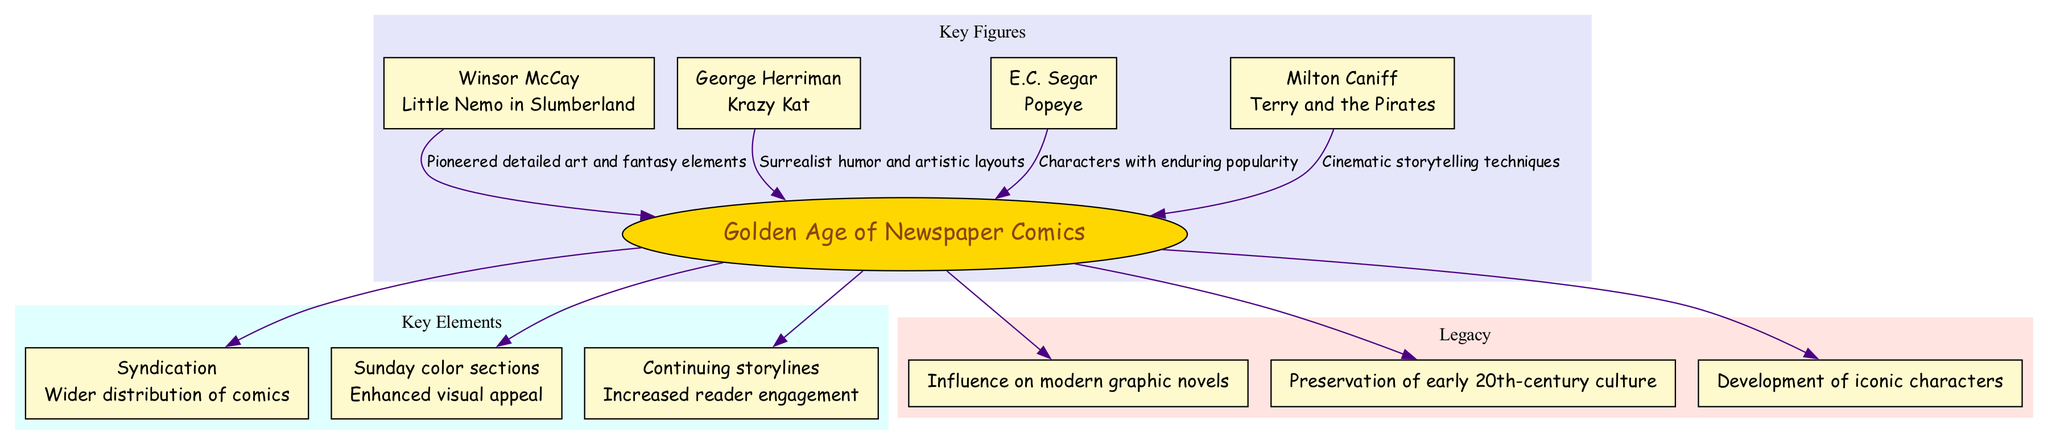What is the central concept of the diagram? The central concept is explicitly labeled in the diagram as the main focus, which is "Golden Age of Newspaper Comics".
Answer: Golden Age of Newspaper Comics How many key figures are included in the diagram? Count the number of nodes listed under the "Key Figures" section in the diagram; there are four distinct figures represented.
Answer: 4 What is the contribution of George Herriman? The diagram shows that George Herriman's contribution is "Krazy Kat," which is clearly stated under his name in the "Key Figures" section.
Answer: Krazy Kat Which element has the impact of "Wider distribution of comics"? The diagram specifies this impact under the element labeled "Syndication," making it easy to identify the connection.
Answer: Syndication What influence did Winsor McCay have? The influence is detailed next to Winsor McCay and is stated as "Pioneered detailed art and fantasy elements." This reflects his contribution to the comics.
Answer: Pioneered detailed art and fantasy elements Which key figure's work is associated with enduring popularity? Referring to E.C. Segar in the diagram, his work is stated to be connected with characters that gained "enduring popularity."
Answer: E.C. Segar What is one legacy mentioned in the diagram? The "Legacy" section identifies several items; one noted item is "Influence on modern graphic novels," showcasing the lasting impact of the Golden Age comics.
Answer: Influence on modern graphic novels What is the impact of the Sunday color sections? The diagram explicitly states that the impact of "Sunday color sections" is to enhance visual appeal, which reflects a significant development in comic presentation.
Answer: Enhanced visual appeal How did Milton Caniff influence storytelling techniques? The diagram connects Milton Caniff to the influence of "Cinematic storytelling techniques," indicating how his work changed the approach to narrative in comics.
Answer: Cinematic storytelling techniques 